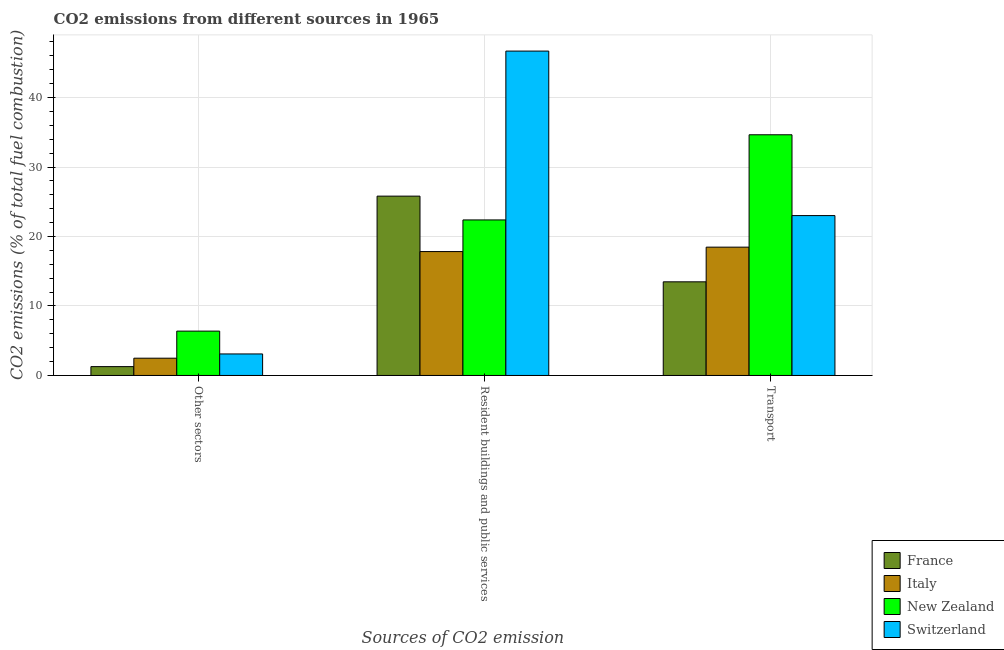How many different coloured bars are there?
Offer a terse response. 4. How many groups of bars are there?
Give a very brief answer. 3. Are the number of bars per tick equal to the number of legend labels?
Give a very brief answer. Yes. What is the label of the 2nd group of bars from the left?
Ensure brevity in your answer.  Resident buildings and public services. What is the percentage of co2 emissions from other sectors in New Zealand?
Offer a terse response. 6.38. Across all countries, what is the maximum percentage of co2 emissions from resident buildings and public services?
Keep it short and to the point. 46.68. Across all countries, what is the minimum percentage of co2 emissions from transport?
Offer a terse response. 13.48. In which country was the percentage of co2 emissions from resident buildings and public services maximum?
Your answer should be compact. Switzerland. What is the total percentage of co2 emissions from resident buildings and public services in the graph?
Provide a succinct answer. 112.7. What is the difference between the percentage of co2 emissions from resident buildings and public services in Switzerland and that in New Zealand?
Make the answer very short. 24.3. What is the difference between the percentage of co2 emissions from resident buildings and public services in Italy and the percentage of co2 emissions from transport in New Zealand?
Keep it short and to the point. -16.81. What is the average percentage of co2 emissions from resident buildings and public services per country?
Provide a succinct answer. 28.18. What is the difference between the percentage of co2 emissions from other sectors and percentage of co2 emissions from transport in Italy?
Offer a terse response. -15.98. What is the ratio of the percentage of co2 emissions from transport in New Zealand to that in Italy?
Offer a terse response. 1.88. Is the percentage of co2 emissions from transport in New Zealand less than that in Italy?
Give a very brief answer. No. What is the difference between the highest and the second highest percentage of co2 emissions from other sectors?
Your response must be concise. 3.29. What is the difference between the highest and the lowest percentage of co2 emissions from other sectors?
Your answer should be very brief. 5.11. In how many countries, is the percentage of co2 emissions from transport greater than the average percentage of co2 emissions from transport taken over all countries?
Keep it short and to the point. 2. What does the 1st bar from the left in Transport represents?
Give a very brief answer. France. Is it the case that in every country, the sum of the percentage of co2 emissions from other sectors and percentage of co2 emissions from resident buildings and public services is greater than the percentage of co2 emissions from transport?
Provide a short and direct response. No. How many bars are there?
Offer a very short reply. 12. Are all the bars in the graph horizontal?
Keep it short and to the point. No. What is the difference between two consecutive major ticks on the Y-axis?
Give a very brief answer. 10. Are the values on the major ticks of Y-axis written in scientific E-notation?
Your answer should be very brief. No. Where does the legend appear in the graph?
Your answer should be compact. Bottom right. What is the title of the graph?
Provide a short and direct response. CO2 emissions from different sources in 1965. Does "Algeria" appear as one of the legend labels in the graph?
Your response must be concise. No. What is the label or title of the X-axis?
Your answer should be very brief. Sources of CO2 emission. What is the label or title of the Y-axis?
Give a very brief answer. CO2 emissions (% of total fuel combustion). What is the CO2 emissions (% of total fuel combustion) in France in Other sectors?
Ensure brevity in your answer.  1.27. What is the CO2 emissions (% of total fuel combustion) of Italy in Other sectors?
Your answer should be very brief. 2.49. What is the CO2 emissions (% of total fuel combustion) of New Zealand in Other sectors?
Keep it short and to the point. 6.38. What is the CO2 emissions (% of total fuel combustion) of Switzerland in Other sectors?
Ensure brevity in your answer.  3.1. What is the CO2 emissions (% of total fuel combustion) of France in Resident buildings and public services?
Give a very brief answer. 25.81. What is the CO2 emissions (% of total fuel combustion) in Italy in Resident buildings and public services?
Offer a very short reply. 17.83. What is the CO2 emissions (% of total fuel combustion) of New Zealand in Resident buildings and public services?
Make the answer very short. 22.38. What is the CO2 emissions (% of total fuel combustion) of Switzerland in Resident buildings and public services?
Ensure brevity in your answer.  46.68. What is the CO2 emissions (% of total fuel combustion) in France in Transport?
Ensure brevity in your answer.  13.48. What is the CO2 emissions (% of total fuel combustion) in Italy in Transport?
Offer a terse response. 18.47. What is the CO2 emissions (% of total fuel combustion) of New Zealand in Transport?
Your answer should be compact. 34.64. What is the CO2 emissions (% of total fuel combustion) of Switzerland in Transport?
Your response must be concise. 23.01. Across all Sources of CO2 emission, what is the maximum CO2 emissions (% of total fuel combustion) of France?
Give a very brief answer. 25.81. Across all Sources of CO2 emission, what is the maximum CO2 emissions (% of total fuel combustion) in Italy?
Keep it short and to the point. 18.47. Across all Sources of CO2 emission, what is the maximum CO2 emissions (% of total fuel combustion) of New Zealand?
Ensure brevity in your answer.  34.64. Across all Sources of CO2 emission, what is the maximum CO2 emissions (% of total fuel combustion) in Switzerland?
Your response must be concise. 46.68. Across all Sources of CO2 emission, what is the minimum CO2 emissions (% of total fuel combustion) of France?
Offer a very short reply. 1.27. Across all Sources of CO2 emission, what is the minimum CO2 emissions (% of total fuel combustion) in Italy?
Make the answer very short. 2.49. Across all Sources of CO2 emission, what is the minimum CO2 emissions (% of total fuel combustion) of New Zealand?
Give a very brief answer. 6.38. Across all Sources of CO2 emission, what is the minimum CO2 emissions (% of total fuel combustion) in Switzerland?
Give a very brief answer. 3.1. What is the total CO2 emissions (% of total fuel combustion) in France in the graph?
Keep it short and to the point. 40.56. What is the total CO2 emissions (% of total fuel combustion) of Italy in the graph?
Your response must be concise. 38.78. What is the total CO2 emissions (% of total fuel combustion) in New Zealand in the graph?
Offer a terse response. 63.4. What is the total CO2 emissions (% of total fuel combustion) in Switzerland in the graph?
Your response must be concise. 72.79. What is the difference between the CO2 emissions (% of total fuel combustion) in France in Other sectors and that in Resident buildings and public services?
Your answer should be compact. -24.53. What is the difference between the CO2 emissions (% of total fuel combustion) of Italy in Other sectors and that in Resident buildings and public services?
Provide a succinct answer. -15.35. What is the difference between the CO2 emissions (% of total fuel combustion) of New Zealand in Other sectors and that in Resident buildings and public services?
Ensure brevity in your answer.  -16. What is the difference between the CO2 emissions (% of total fuel combustion) of Switzerland in Other sectors and that in Resident buildings and public services?
Your answer should be very brief. -43.58. What is the difference between the CO2 emissions (% of total fuel combustion) of France in Other sectors and that in Transport?
Offer a very short reply. -12.2. What is the difference between the CO2 emissions (% of total fuel combustion) of Italy in Other sectors and that in Transport?
Keep it short and to the point. -15.98. What is the difference between the CO2 emissions (% of total fuel combustion) in New Zealand in Other sectors and that in Transport?
Make the answer very short. -28.26. What is the difference between the CO2 emissions (% of total fuel combustion) in Switzerland in Other sectors and that in Transport?
Offer a very short reply. -19.91. What is the difference between the CO2 emissions (% of total fuel combustion) in France in Resident buildings and public services and that in Transport?
Give a very brief answer. 12.33. What is the difference between the CO2 emissions (% of total fuel combustion) of Italy in Resident buildings and public services and that in Transport?
Give a very brief answer. -0.64. What is the difference between the CO2 emissions (% of total fuel combustion) in New Zealand in Resident buildings and public services and that in Transport?
Make the answer very short. -12.26. What is the difference between the CO2 emissions (% of total fuel combustion) of Switzerland in Resident buildings and public services and that in Transport?
Offer a terse response. 23.67. What is the difference between the CO2 emissions (% of total fuel combustion) in France in Other sectors and the CO2 emissions (% of total fuel combustion) in Italy in Resident buildings and public services?
Provide a short and direct response. -16.56. What is the difference between the CO2 emissions (% of total fuel combustion) of France in Other sectors and the CO2 emissions (% of total fuel combustion) of New Zealand in Resident buildings and public services?
Ensure brevity in your answer.  -21.11. What is the difference between the CO2 emissions (% of total fuel combustion) of France in Other sectors and the CO2 emissions (% of total fuel combustion) of Switzerland in Resident buildings and public services?
Give a very brief answer. -45.41. What is the difference between the CO2 emissions (% of total fuel combustion) in Italy in Other sectors and the CO2 emissions (% of total fuel combustion) in New Zealand in Resident buildings and public services?
Provide a succinct answer. -19.9. What is the difference between the CO2 emissions (% of total fuel combustion) in Italy in Other sectors and the CO2 emissions (% of total fuel combustion) in Switzerland in Resident buildings and public services?
Your response must be concise. -44.2. What is the difference between the CO2 emissions (% of total fuel combustion) in New Zealand in Other sectors and the CO2 emissions (% of total fuel combustion) in Switzerland in Resident buildings and public services?
Give a very brief answer. -40.3. What is the difference between the CO2 emissions (% of total fuel combustion) in France in Other sectors and the CO2 emissions (% of total fuel combustion) in Italy in Transport?
Provide a succinct answer. -17.19. What is the difference between the CO2 emissions (% of total fuel combustion) in France in Other sectors and the CO2 emissions (% of total fuel combustion) in New Zealand in Transport?
Your response must be concise. -33.36. What is the difference between the CO2 emissions (% of total fuel combustion) of France in Other sectors and the CO2 emissions (% of total fuel combustion) of Switzerland in Transport?
Keep it short and to the point. -21.73. What is the difference between the CO2 emissions (% of total fuel combustion) in Italy in Other sectors and the CO2 emissions (% of total fuel combustion) in New Zealand in Transport?
Offer a very short reply. -32.15. What is the difference between the CO2 emissions (% of total fuel combustion) of Italy in Other sectors and the CO2 emissions (% of total fuel combustion) of Switzerland in Transport?
Your answer should be compact. -20.52. What is the difference between the CO2 emissions (% of total fuel combustion) of New Zealand in Other sectors and the CO2 emissions (% of total fuel combustion) of Switzerland in Transport?
Your answer should be compact. -16.63. What is the difference between the CO2 emissions (% of total fuel combustion) of France in Resident buildings and public services and the CO2 emissions (% of total fuel combustion) of Italy in Transport?
Your answer should be very brief. 7.34. What is the difference between the CO2 emissions (% of total fuel combustion) of France in Resident buildings and public services and the CO2 emissions (% of total fuel combustion) of New Zealand in Transport?
Your answer should be compact. -8.83. What is the difference between the CO2 emissions (% of total fuel combustion) of France in Resident buildings and public services and the CO2 emissions (% of total fuel combustion) of Switzerland in Transport?
Your response must be concise. 2.8. What is the difference between the CO2 emissions (% of total fuel combustion) of Italy in Resident buildings and public services and the CO2 emissions (% of total fuel combustion) of New Zealand in Transport?
Your response must be concise. -16.81. What is the difference between the CO2 emissions (% of total fuel combustion) in Italy in Resident buildings and public services and the CO2 emissions (% of total fuel combustion) in Switzerland in Transport?
Keep it short and to the point. -5.18. What is the difference between the CO2 emissions (% of total fuel combustion) of New Zealand in Resident buildings and public services and the CO2 emissions (% of total fuel combustion) of Switzerland in Transport?
Your response must be concise. -0.63. What is the average CO2 emissions (% of total fuel combustion) in France per Sources of CO2 emission?
Provide a succinct answer. 13.52. What is the average CO2 emissions (% of total fuel combustion) in Italy per Sources of CO2 emission?
Offer a terse response. 12.93. What is the average CO2 emissions (% of total fuel combustion) of New Zealand per Sources of CO2 emission?
Provide a short and direct response. 21.13. What is the average CO2 emissions (% of total fuel combustion) in Switzerland per Sources of CO2 emission?
Provide a short and direct response. 24.26. What is the difference between the CO2 emissions (% of total fuel combustion) of France and CO2 emissions (% of total fuel combustion) of Italy in Other sectors?
Provide a succinct answer. -1.21. What is the difference between the CO2 emissions (% of total fuel combustion) of France and CO2 emissions (% of total fuel combustion) of New Zealand in Other sectors?
Keep it short and to the point. -5.11. What is the difference between the CO2 emissions (% of total fuel combustion) of France and CO2 emissions (% of total fuel combustion) of Switzerland in Other sectors?
Provide a short and direct response. -1.82. What is the difference between the CO2 emissions (% of total fuel combustion) in Italy and CO2 emissions (% of total fuel combustion) in New Zealand in Other sectors?
Give a very brief answer. -3.9. What is the difference between the CO2 emissions (% of total fuel combustion) of Italy and CO2 emissions (% of total fuel combustion) of Switzerland in Other sectors?
Provide a succinct answer. -0.61. What is the difference between the CO2 emissions (% of total fuel combustion) of New Zealand and CO2 emissions (% of total fuel combustion) of Switzerland in Other sectors?
Your response must be concise. 3.29. What is the difference between the CO2 emissions (% of total fuel combustion) in France and CO2 emissions (% of total fuel combustion) in Italy in Resident buildings and public services?
Your response must be concise. 7.98. What is the difference between the CO2 emissions (% of total fuel combustion) of France and CO2 emissions (% of total fuel combustion) of New Zealand in Resident buildings and public services?
Provide a short and direct response. 3.42. What is the difference between the CO2 emissions (% of total fuel combustion) of France and CO2 emissions (% of total fuel combustion) of Switzerland in Resident buildings and public services?
Your answer should be very brief. -20.87. What is the difference between the CO2 emissions (% of total fuel combustion) in Italy and CO2 emissions (% of total fuel combustion) in New Zealand in Resident buildings and public services?
Make the answer very short. -4.55. What is the difference between the CO2 emissions (% of total fuel combustion) in Italy and CO2 emissions (% of total fuel combustion) in Switzerland in Resident buildings and public services?
Your response must be concise. -28.85. What is the difference between the CO2 emissions (% of total fuel combustion) in New Zealand and CO2 emissions (% of total fuel combustion) in Switzerland in Resident buildings and public services?
Provide a short and direct response. -24.3. What is the difference between the CO2 emissions (% of total fuel combustion) in France and CO2 emissions (% of total fuel combustion) in Italy in Transport?
Give a very brief answer. -4.99. What is the difference between the CO2 emissions (% of total fuel combustion) of France and CO2 emissions (% of total fuel combustion) of New Zealand in Transport?
Ensure brevity in your answer.  -21.16. What is the difference between the CO2 emissions (% of total fuel combustion) of France and CO2 emissions (% of total fuel combustion) of Switzerland in Transport?
Give a very brief answer. -9.53. What is the difference between the CO2 emissions (% of total fuel combustion) in Italy and CO2 emissions (% of total fuel combustion) in New Zealand in Transport?
Ensure brevity in your answer.  -16.17. What is the difference between the CO2 emissions (% of total fuel combustion) of Italy and CO2 emissions (% of total fuel combustion) of Switzerland in Transport?
Keep it short and to the point. -4.54. What is the difference between the CO2 emissions (% of total fuel combustion) of New Zealand and CO2 emissions (% of total fuel combustion) of Switzerland in Transport?
Give a very brief answer. 11.63. What is the ratio of the CO2 emissions (% of total fuel combustion) in France in Other sectors to that in Resident buildings and public services?
Offer a very short reply. 0.05. What is the ratio of the CO2 emissions (% of total fuel combustion) in Italy in Other sectors to that in Resident buildings and public services?
Your answer should be compact. 0.14. What is the ratio of the CO2 emissions (% of total fuel combustion) of New Zealand in Other sectors to that in Resident buildings and public services?
Offer a terse response. 0.29. What is the ratio of the CO2 emissions (% of total fuel combustion) in Switzerland in Other sectors to that in Resident buildings and public services?
Make the answer very short. 0.07. What is the ratio of the CO2 emissions (% of total fuel combustion) in France in Other sectors to that in Transport?
Offer a very short reply. 0.09. What is the ratio of the CO2 emissions (% of total fuel combustion) in Italy in Other sectors to that in Transport?
Your answer should be very brief. 0.13. What is the ratio of the CO2 emissions (% of total fuel combustion) of New Zealand in Other sectors to that in Transport?
Your answer should be compact. 0.18. What is the ratio of the CO2 emissions (% of total fuel combustion) in Switzerland in Other sectors to that in Transport?
Your answer should be very brief. 0.13. What is the ratio of the CO2 emissions (% of total fuel combustion) of France in Resident buildings and public services to that in Transport?
Provide a succinct answer. 1.92. What is the ratio of the CO2 emissions (% of total fuel combustion) in Italy in Resident buildings and public services to that in Transport?
Keep it short and to the point. 0.97. What is the ratio of the CO2 emissions (% of total fuel combustion) in New Zealand in Resident buildings and public services to that in Transport?
Give a very brief answer. 0.65. What is the ratio of the CO2 emissions (% of total fuel combustion) in Switzerland in Resident buildings and public services to that in Transport?
Offer a terse response. 2.03. What is the difference between the highest and the second highest CO2 emissions (% of total fuel combustion) in France?
Your answer should be compact. 12.33. What is the difference between the highest and the second highest CO2 emissions (% of total fuel combustion) of Italy?
Keep it short and to the point. 0.64. What is the difference between the highest and the second highest CO2 emissions (% of total fuel combustion) in New Zealand?
Provide a short and direct response. 12.26. What is the difference between the highest and the second highest CO2 emissions (% of total fuel combustion) of Switzerland?
Give a very brief answer. 23.67. What is the difference between the highest and the lowest CO2 emissions (% of total fuel combustion) in France?
Your answer should be compact. 24.53. What is the difference between the highest and the lowest CO2 emissions (% of total fuel combustion) of Italy?
Your response must be concise. 15.98. What is the difference between the highest and the lowest CO2 emissions (% of total fuel combustion) in New Zealand?
Provide a short and direct response. 28.26. What is the difference between the highest and the lowest CO2 emissions (% of total fuel combustion) in Switzerland?
Provide a succinct answer. 43.58. 